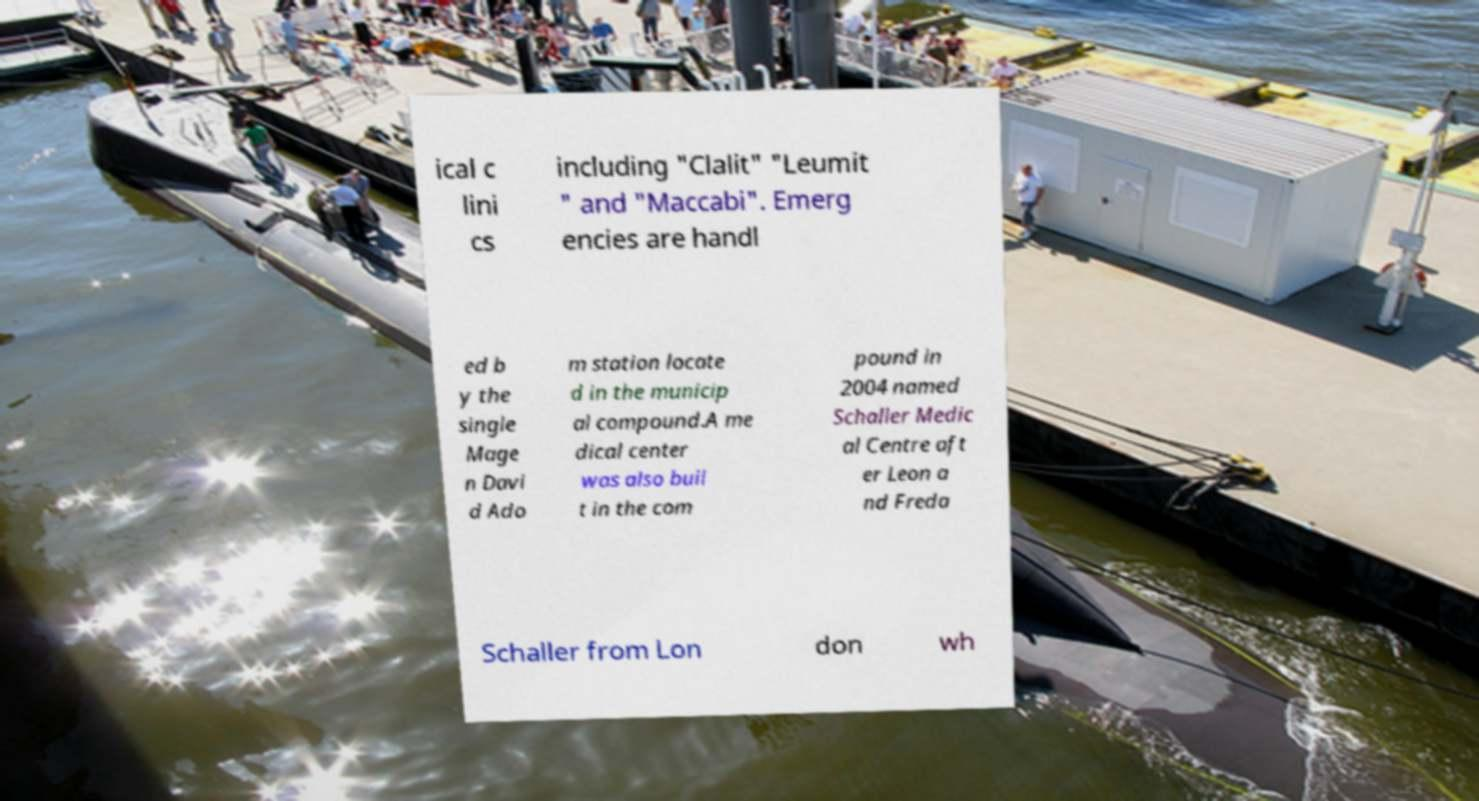Can you read and provide the text displayed in the image?This photo seems to have some interesting text. Can you extract and type it out for me? ical c lini cs including "Clalit" "Leumit " and "Maccabi". Emerg encies are handl ed b y the single Mage n Davi d Ado m station locate d in the municip al compound.A me dical center was also buil t in the com pound in 2004 named Schaller Medic al Centre aft er Leon a nd Freda Schaller from Lon don wh 